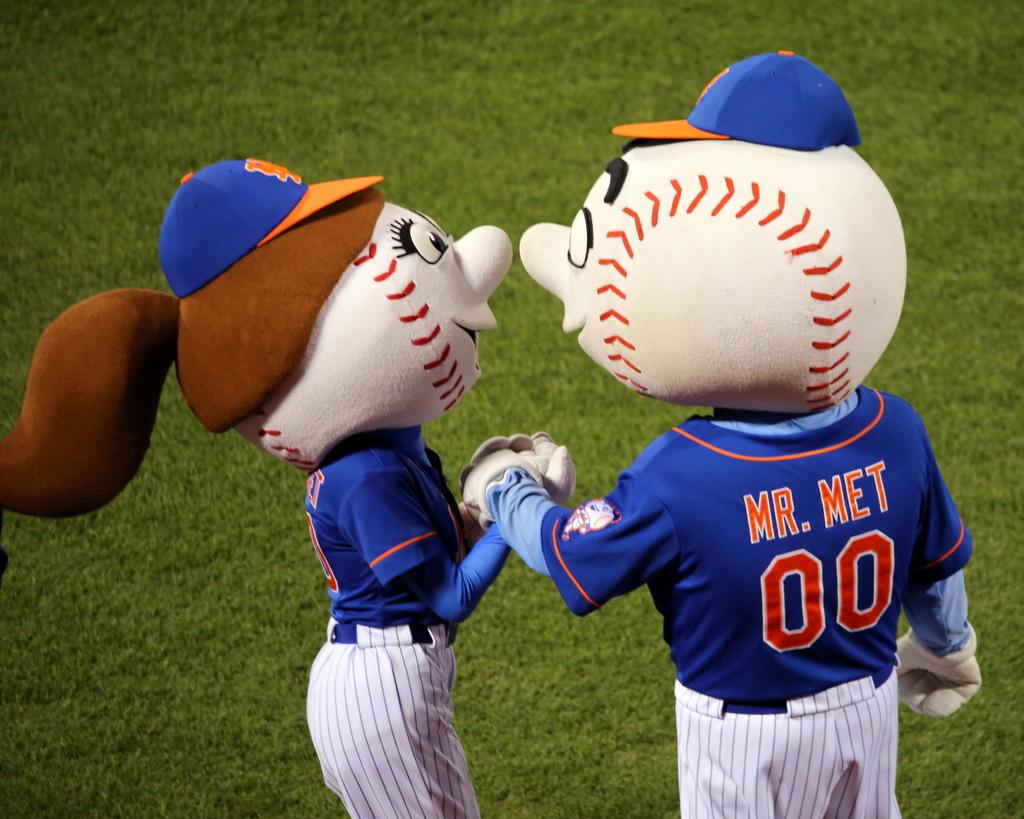What is the mascot's name?
Make the answer very short. Mr. met. What number is on the mascots jersey?
Your response must be concise. 00. 